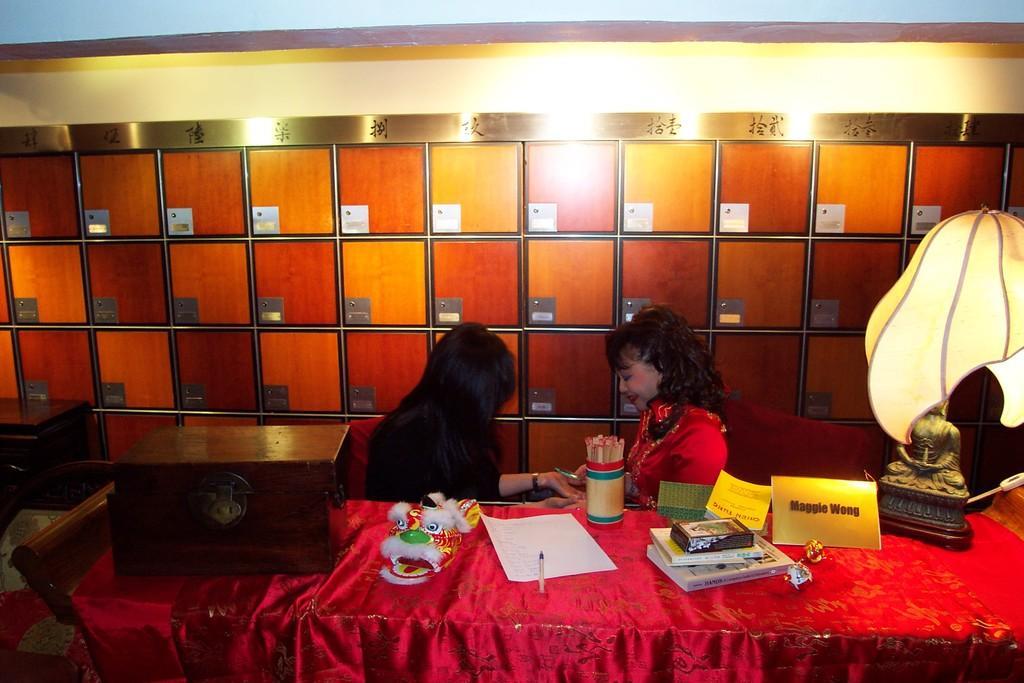How would you summarize this image in a sentence or two? In this image I can see there are two persons, among them one is a woman and other is a girl. On the table we have pen, a paper, few books and other stuff on it. 